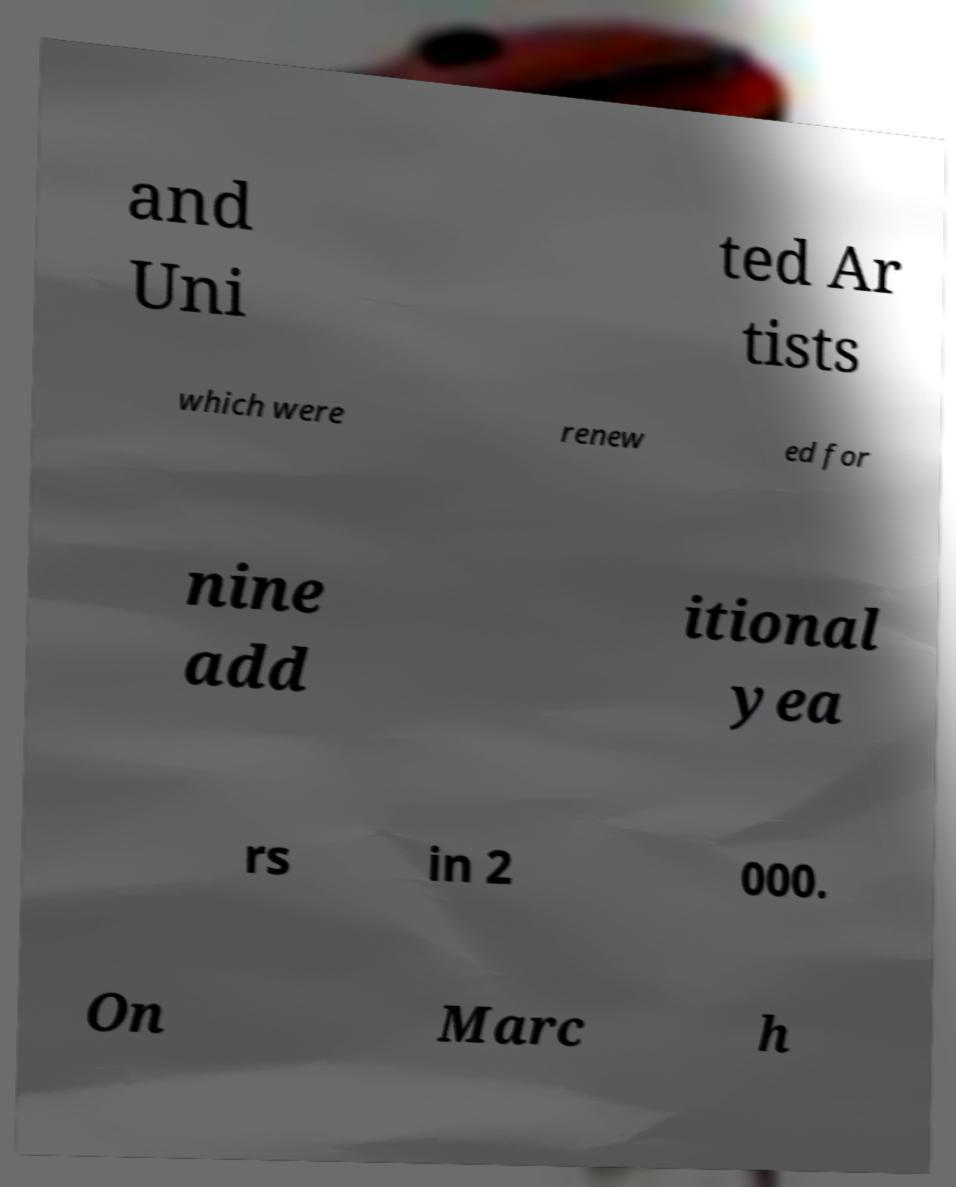What messages or text are displayed in this image? I need them in a readable, typed format. and Uni ted Ar tists which were renew ed for nine add itional yea rs in 2 000. On Marc h 